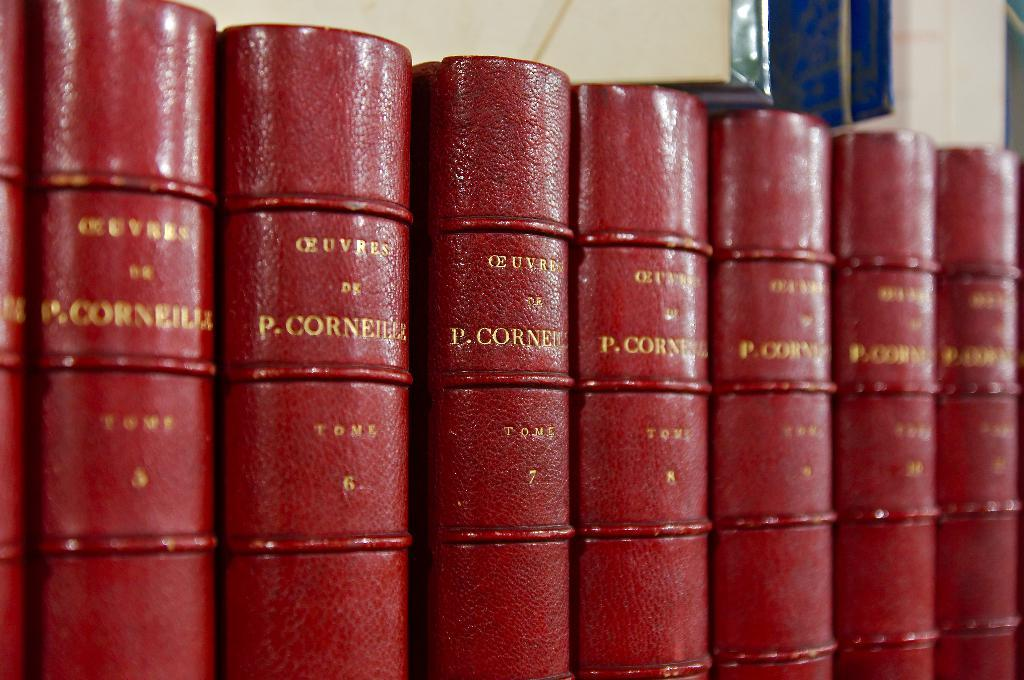<image>
Summarize the visual content of the image. Books bound in red show which volume they are and the name P.Corneille. 